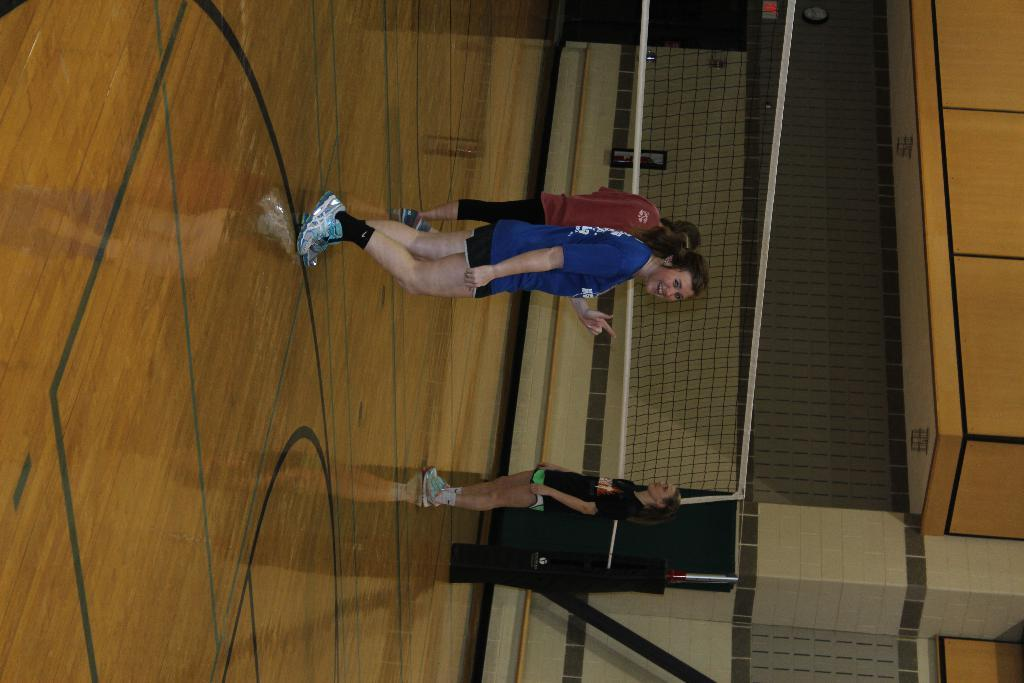How many people are present in the image? There are three people in the image. What is one person wearing? One person is wearing a blue dress. What is the woman wearing? The woman is wearing a black dress. What can be seen in the image besides the people? There is a net and a wall in the image. What type of wave can be seen crashing against the wall in the image? There is no wave present in the image; it features three people, a net, and a wall. 